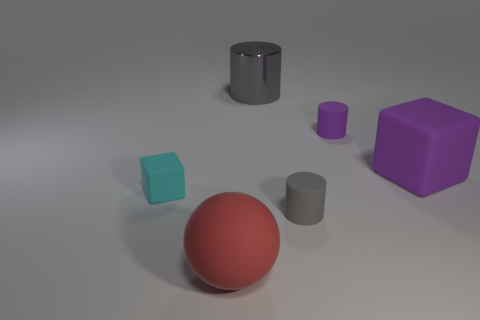Subtract all big gray metallic cylinders. How many cylinders are left? 2 Subtract all blue blocks. How many gray cylinders are left? 2 Add 3 brown matte spheres. How many objects exist? 9 Subtract all blocks. How many objects are left? 4 Add 6 gray matte things. How many gray matte things exist? 7 Subtract 1 purple cubes. How many objects are left? 5 Subtract all red cylinders. Subtract all gray balls. How many cylinders are left? 3 Subtract all purple matte things. Subtract all big cylinders. How many objects are left? 3 Add 4 big red things. How many big red things are left? 5 